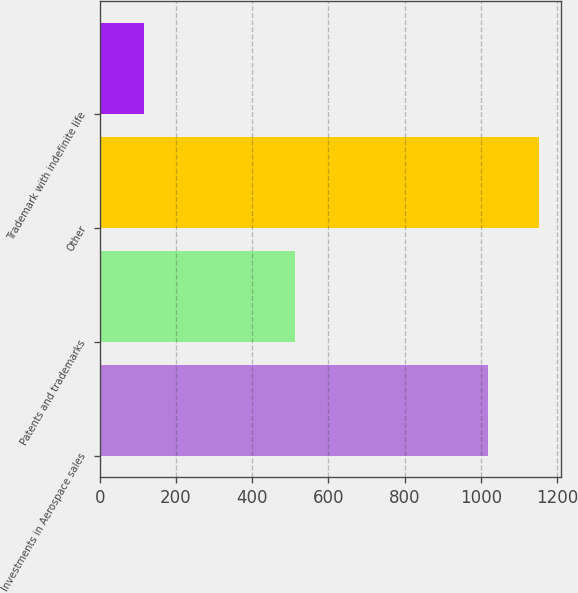Convert chart to OTSL. <chart><loc_0><loc_0><loc_500><loc_500><bar_chart><fcel>Investments in Aerospace sales<fcel>Patents and trademarks<fcel>Other<fcel>Trademark with indefinite life<nl><fcel>1018<fcel>512<fcel>1153<fcel>116<nl></chart> 